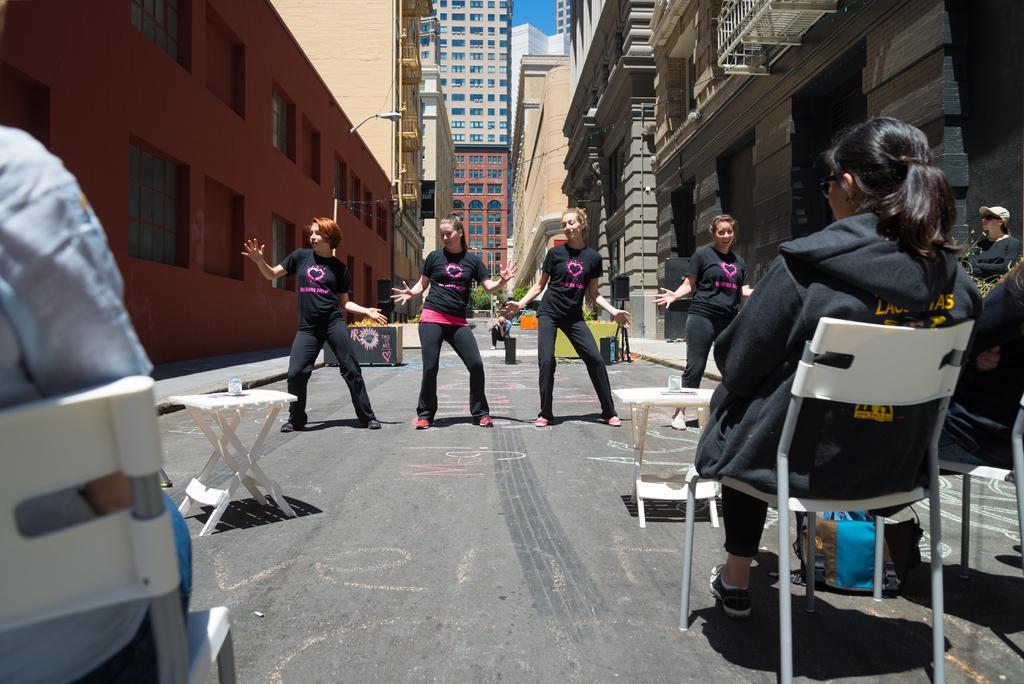Can you describe this image briefly? In the image I can see four people who are dancing and also I can see some other people who are sitting who are sitting on the chairs and also I can see some buildings. 